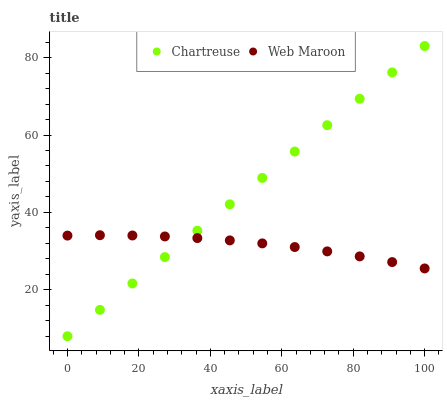Does Web Maroon have the minimum area under the curve?
Answer yes or no. Yes. Does Chartreuse have the maximum area under the curve?
Answer yes or no. Yes. Does Web Maroon have the maximum area under the curve?
Answer yes or no. No. Is Chartreuse the smoothest?
Answer yes or no. Yes. Is Web Maroon the roughest?
Answer yes or no. Yes. Is Web Maroon the smoothest?
Answer yes or no. No. Does Chartreuse have the lowest value?
Answer yes or no. Yes. Does Web Maroon have the lowest value?
Answer yes or no. No. Does Chartreuse have the highest value?
Answer yes or no. Yes. Does Web Maroon have the highest value?
Answer yes or no. No. Does Chartreuse intersect Web Maroon?
Answer yes or no. Yes. Is Chartreuse less than Web Maroon?
Answer yes or no. No. Is Chartreuse greater than Web Maroon?
Answer yes or no. No. 